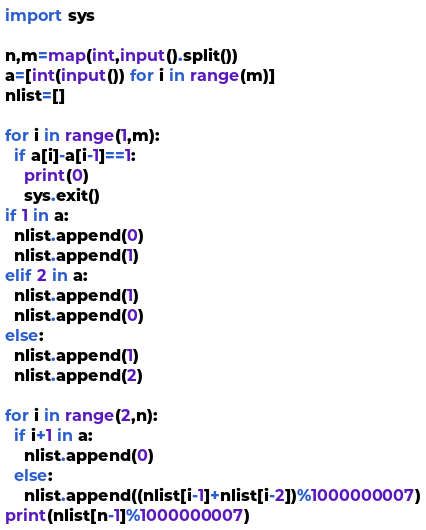Convert code to text. <code><loc_0><loc_0><loc_500><loc_500><_Python_>import sys

n,m=map(int,input().split())
a=[int(input()) for i in range(m)]
nlist=[]

for i in range(1,m):
  if a[i]-a[i-1]==1:
    print(0)
    sys.exit()
if 1 in a:
  nlist.append(0)
  nlist.append(1)
elif 2 in a:
  nlist.append(1)
  nlist.append(0)
else:
  nlist.append(1)
  nlist.append(2)

for i in range(2,n):
  if i+1 in a:
    nlist.append(0)
  else:
    nlist.append((nlist[i-1]+nlist[i-2])%1000000007)
print(nlist[n-1]%1000000007)</code> 